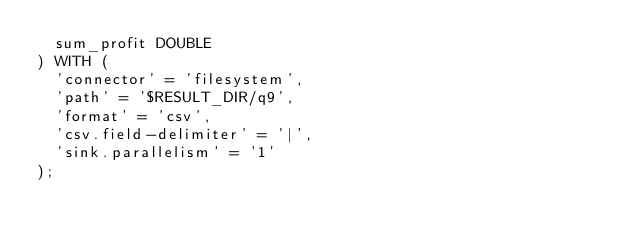Convert code to text. <code><loc_0><loc_0><loc_500><loc_500><_SQL_>  sum_profit DOUBLE
) WITH (
  'connector' = 'filesystem',
  'path' = '$RESULT_DIR/q9',
  'format' = 'csv',
  'csv.field-delimiter' = '|',
  'sink.parallelism' = '1'
);
</code> 